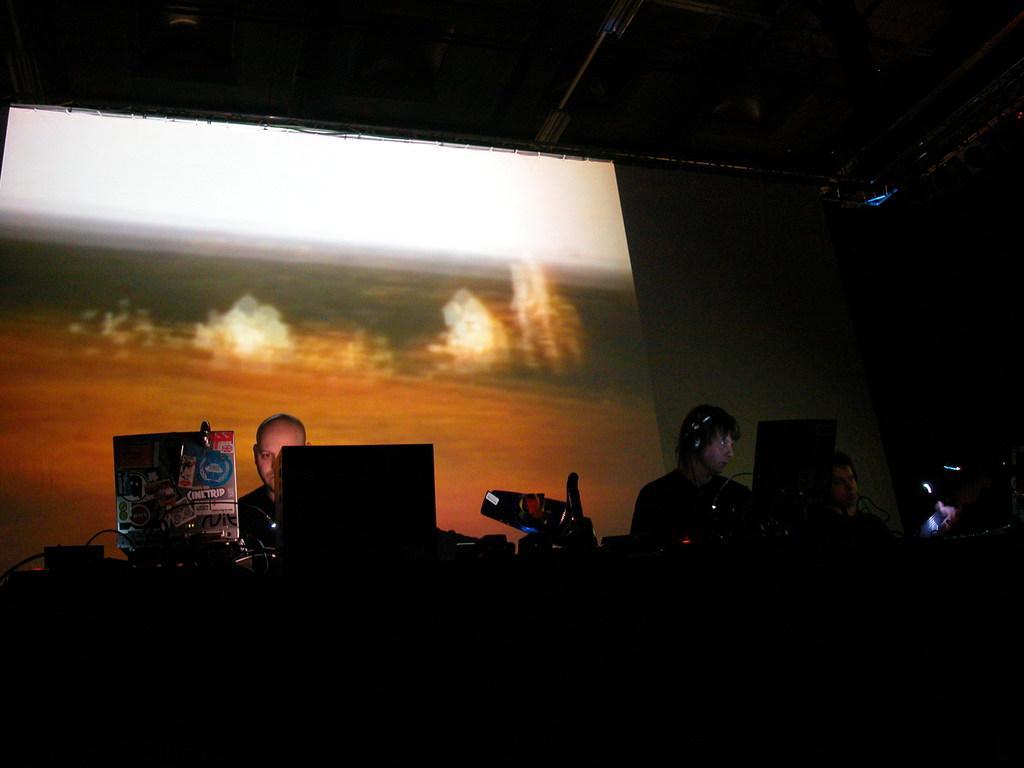How would you summarize this image in a sentence or two? In this image I can see the group of people. In-front of these people I can see the wires, board and many electronic gadgets. In the background I can see the screen. 